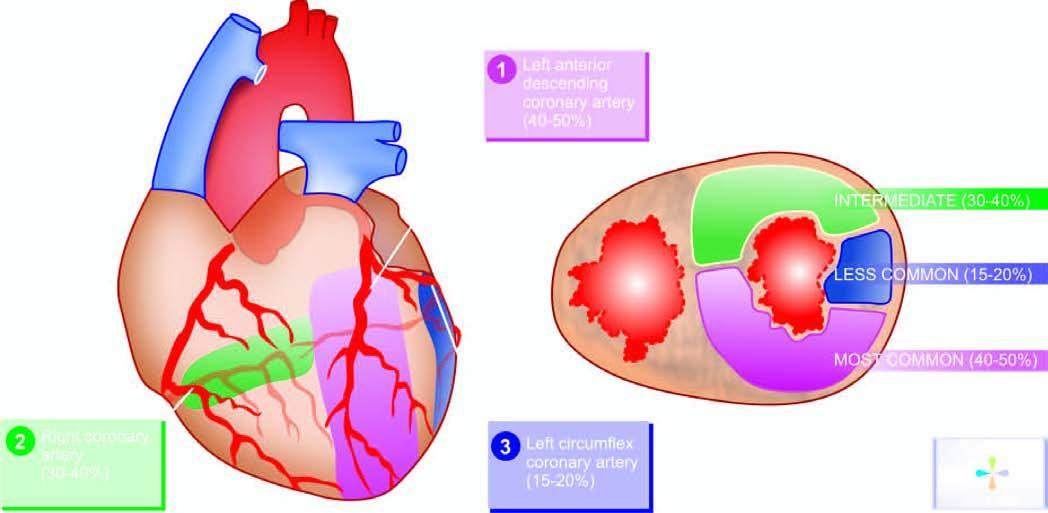re strands in myocardial infarction?
Answer the question using a single word or phrase. No 